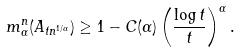<formula> <loc_0><loc_0><loc_500><loc_500>m _ { \alpha } ^ { n } ( A _ { t n ^ { 1 / \alpha } } ) \geq 1 - C ( \alpha ) \left ( \frac { \log t } { t } \right ) ^ { \alpha } .</formula> 